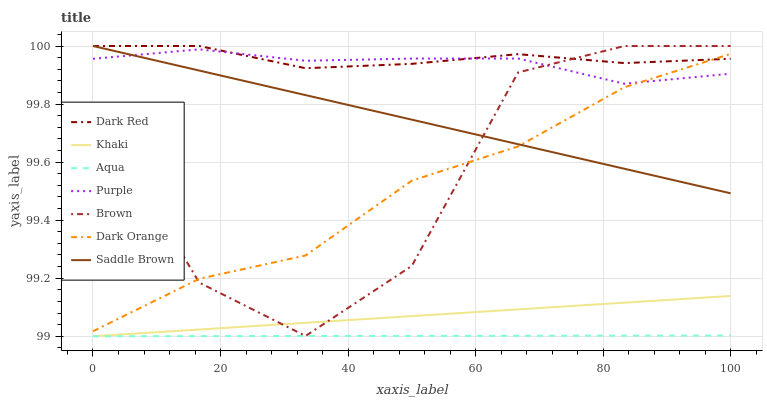Does Aqua have the minimum area under the curve?
Answer yes or no. Yes. Does Dark Red have the maximum area under the curve?
Answer yes or no. Yes. Does Khaki have the minimum area under the curve?
Answer yes or no. No. Does Khaki have the maximum area under the curve?
Answer yes or no. No. Is Aqua the smoothest?
Answer yes or no. Yes. Is Brown the roughest?
Answer yes or no. Yes. Is Khaki the smoothest?
Answer yes or no. No. Is Khaki the roughest?
Answer yes or no. No. Does Khaki have the lowest value?
Answer yes or no. Yes. Does Brown have the lowest value?
Answer yes or no. No. Does Saddle Brown have the highest value?
Answer yes or no. Yes. Does Khaki have the highest value?
Answer yes or no. No. Is Khaki less than Saddle Brown?
Answer yes or no. Yes. Is Saddle Brown greater than Khaki?
Answer yes or no. Yes. Does Dark Red intersect Purple?
Answer yes or no. Yes. Is Dark Red less than Purple?
Answer yes or no. No. Is Dark Red greater than Purple?
Answer yes or no. No. Does Khaki intersect Saddle Brown?
Answer yes or no. No. 